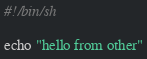<code> <loc_0><loc_0><loc_500><loc_500><_Bash_>#!/bin/sh

echo "hello from other"</code> 